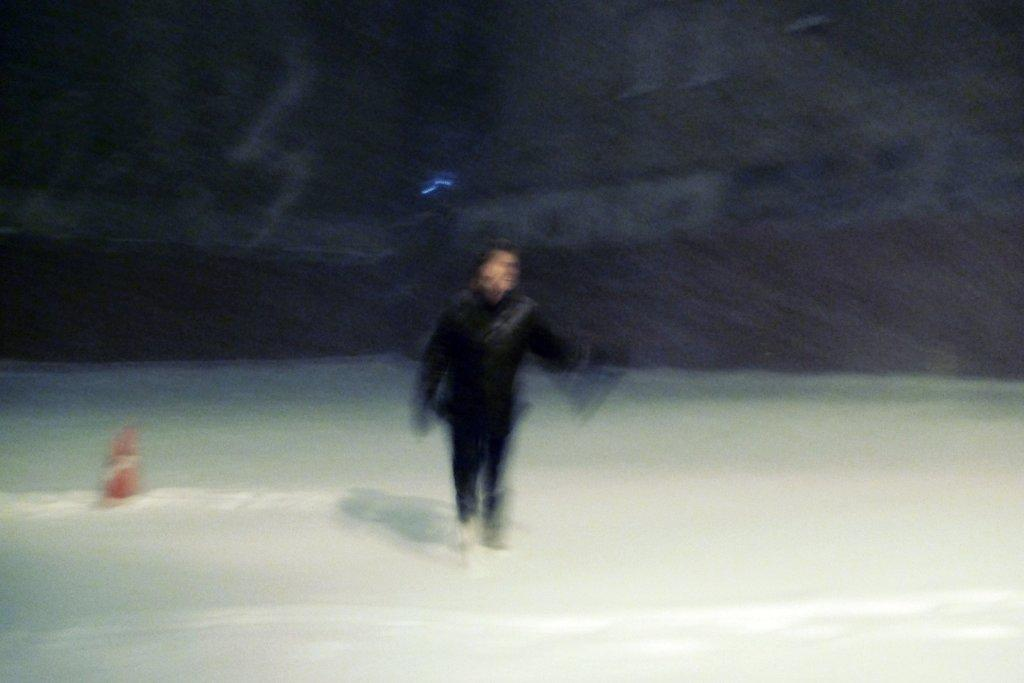What is the main subject of the image? There is a man standing in the image. What object can be seen on the left side of the image? There is a traffic cone on the left side of the image. What type of weather is depicted in the image? Snow is present on the land in the image. How would you describe the background of the image? The background of the image is blurry. How does the man show his support for the heart in the image? There is no heart present in the image, so it is not possible to determine how the man might show support for it. 